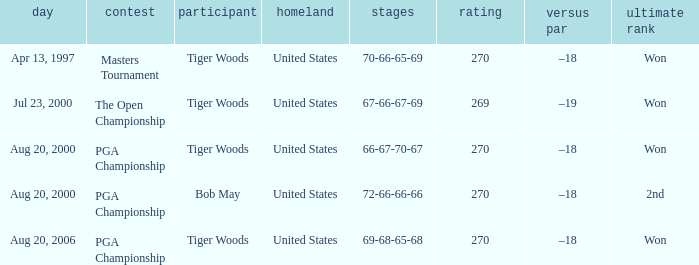What days were the rounds of 66-67-70-67 recorded? Aug 20, 2000. 